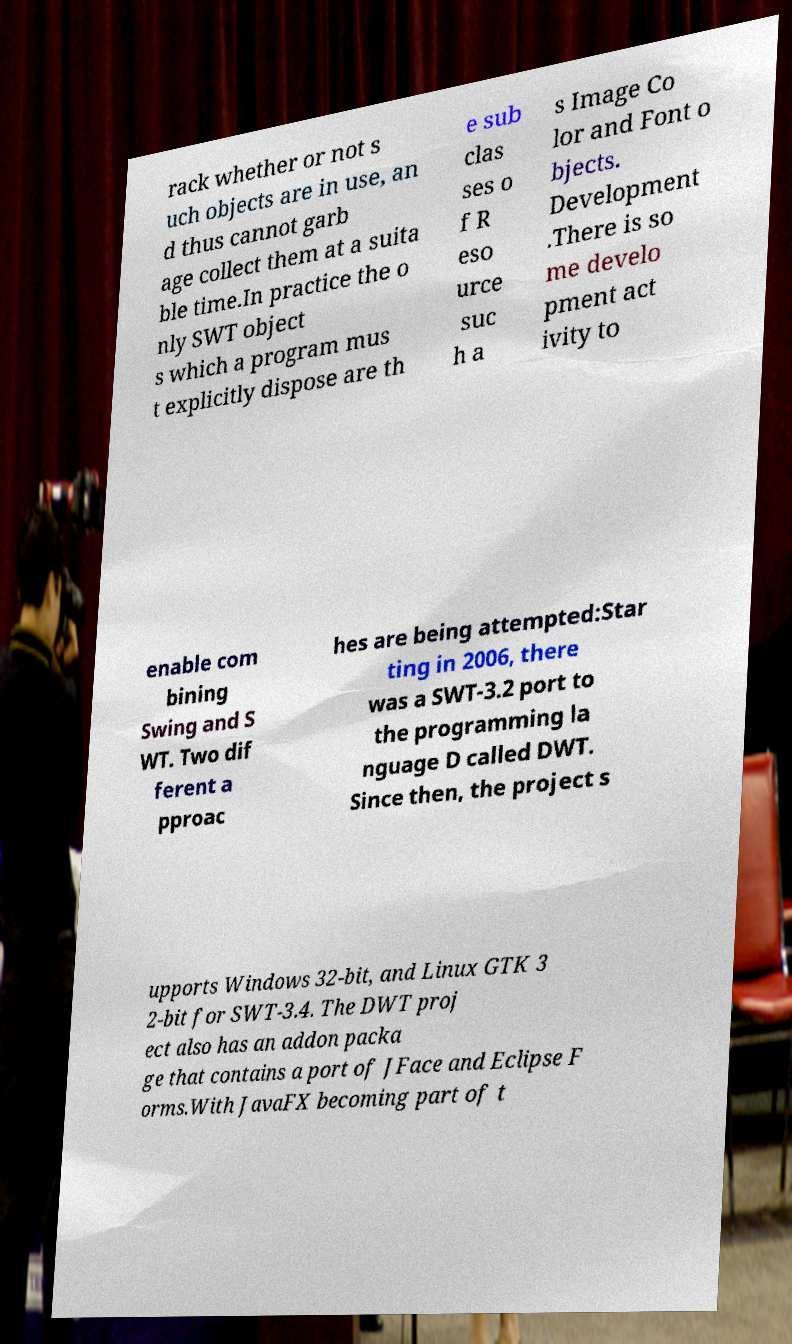Please read and relay the text visible in this image. What does it say? rack whether or not s uch objects are in use, an d thus cannot garb age collect them at a suita ble time.In practice the o nly SWT object s which a program mus t explicitly dispose are th e sub clas ses o f R eso urce suc h a s Image Co lor and Font o bjects. Development .There is so me develo pment act ivity to enable com bining Swing and S WT. Two dif ferent a pproac hes are being attempted:Star ting in 2006, there was a SWT-3.2 port to the programming la nguage D called DWT. Since then, the project s upports Windows 32-bit, and Linux GTK 3 2-bit for SWT-3.4. The DWT proj ect also has an addon packa ge that contains a port of JFace and Eclipse F orms.With JavaFX becoming part of t 